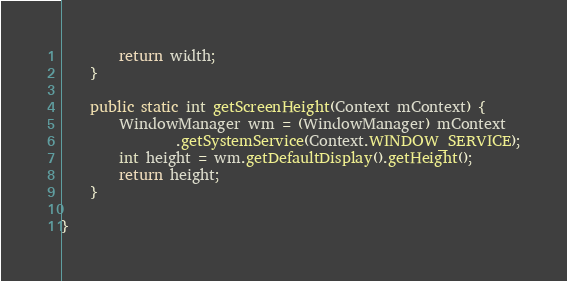<code> <loc_0><loc_0><loc_500><loc_500><_Java_>        return width;
    }

    public static int getScreenHeight(Context mContext) {
        WindowManager wm = (WindowManager) mContext
                .getSystemService(Context.WINDOW_SERVICE);
        int height = wm.getDefaultDisplay().getHeight();
        return height;
    }

}</code> 